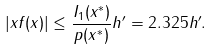<formula> <loc_0><loc_0><loc_500><loc_500>| x f ( x ) | \leq \frac { I _ { 1 } ( x ^ { * } ) } { p ( x ^ { * } ) } \| h ^ { \prime } \| = 2 . 3 2 5 \| h ^ { \prime } \| .</formula> 